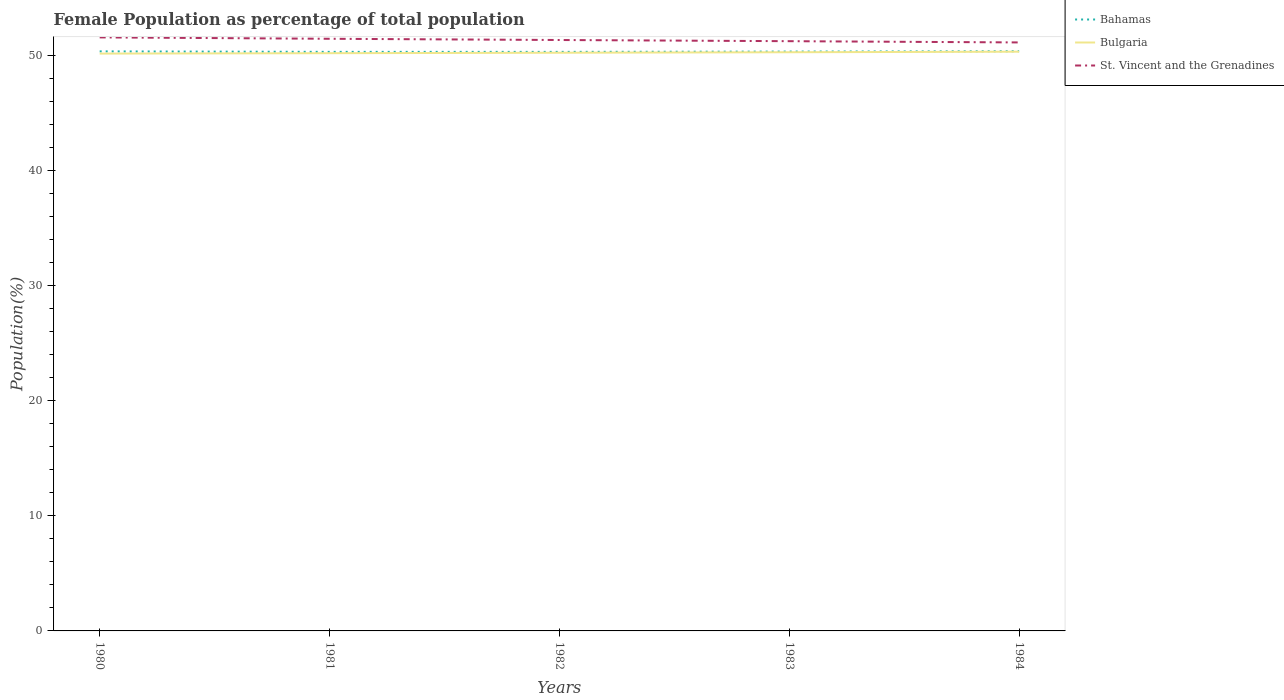Does the line corresponding to St. Vincent and the Grenadines intersect with the line corresponding to Bulgaria?
Your response must be concise. No. Is the number of lines equal to the number of legend labels?
Give a very brief answer. Yes. Across all years, what is the maximum female population in in St. Vincent and the Grenadines?
Ensure brevity in your answer.  51.13. In which year was the female population in in St. Vincent and the Grenadines maximum?
Make the answer very short. 1984. What is the total female population in in Bahamas in the graph?
Your answer should be compact. 0. What is the difference between the highest and the second highest female population in in Bahamas?
Ensure brevity in your answer.  0.05. What is the difference between the highest and the lowest female population in in St. Vincent and the Grenadines?
Ensure brevity in your answer.  2. Is the female population in in Bulgaria strictly greater than the female population in in St. Vincent and the Grenadines over the years?
Provide a succinct answer. Yes. How many lines are there?
Your response must be concise. 3. How many years are there in the graph?
Offer a terse response. 5. What is the difference between two consecutive major ticks on the Y-axis?
Make the answer very short. 10. Does the graph contain any zero values?
Your response must be concise. No. Does the graph contain grids?
Provide a short and direct response. No. Where does the legend appear in the graph?
Your response must be concise. Top right. How many legend labels are there?
Provide a short and direct response. 3. What is the title of the graph?
Your answer should be compact. Female Population as percentage of total population. Does "St. Martin (French part)" appear as one of the legend labels in the graph?
Your answer should be compact. No. What is the label or title of the Y-axis?
Make the answer very short. Population(%). What is the Population(%) of Bahamas in 1980?
Provide a short and direct response. 50.36. What is the Population(%) in Bulgaria in 1980?
Provide a short and direct response. 50.16. What is the Population(%) of St. Vincent and the Grenadines in 1980?
Your answer should be compact. 51.57. What is the Population(%) of Bahamas in 1981?
Your response must be concise. 50.31. What is the Population(%) of Bulgaria in 1981?
Give a very brief answer. 50.2. What is the Population(%) of St. Vincent and the Grenadines in 1981?
Offer a very short reply. 51.45. What is the Population(%) in Bahamas in 1982?
Offer a very short reply. 50.31. What is the Population(%) of Bulgaria in 1982?
Your answer should be very brief. 50.24. What is the Population(%) in St. Vincent and the Grenadines in 1982?
Offer a very short reply. 51.34. What is the Population(%) of Bahamas in 1983?
Give a very brief answer. 50.34. What is the Population(%) of Bulgaria in 1983?
Your answer should be compact. 50.28. What is the Population(%) in St. Vincent and the Grenadines in 1983?
Your answer should be compact. 51.24. What is the Population(%) of Bahamas in 1984?
Keep it short and to the point. 50.37. What is the Population(%) of Bulgaria in 1984?
Your response must be concise. 50.33. What is the Population(%) of St. Vincent and the Grenadines in 1984?
Your answer should be very brief. 51.13. Across all years, what is the maximum Population(%) in Bahamas?
Ensure brevity in your answer.  50.37. Across all years, what is the maximum Population(%) of Bulgaria?
Give a very brief answer. 50.33. Across all years, what is the maximum Population(%) of St. Vincent and the Grenadines?
Make the answer very short. 51.57. Across all years, what is the minimum Population(%) in Bahamas?
Provide a succinct answer. 50.31. Across all years, what is the minimum Population(%) of Bulgaria?
Offer a very short reply. 50.16. Across all years, what is the minimum Population(%) of St. Vincent and the Grenadines?
Provide a succinct answer. 51.13. What is the total Population(%) of Bahamas in the graph?
Your answer should be very brief. 251.69. What is the total Population(%) in Bulgaria in the graph?
Offer a terse response. 251.21. What is the total Population(%) in St. Vincent and the Grenadines in the graph?
Your answer should be very brief. 256.74. What is the difference between the Population(%) of Bahamas in 1980 and that in 1981?
Make the answer very short. 0.04. What is the difference between the Population(%) of Bulgaria in 1980 and that in 1981?
Provide a succinct answer. -0.03. What is the difference between the Population(%) of St. Vincent and the Grenadines in 1980 and that in 1981?
Keep it short and to the point. 0.12. What is the difference between the Population(%) of Bahamas in 1980 and that in 1982?
Your response must be concise. 0.04. What is the difference between the Population(%) of Bulgaria in 1980 and that in 1982?
Offer a terse response. -0.07. What is the difference between the Population(%) of St. Vincent and the Grenadines in 1980 and that in 1982?
Your answer should be compact. 0.23. What is the difference between the Population(%) of Bahamas in 1980 and that in 1983?
Your answer should be very brief. 0.02. What is the difference between the Population(%) in Bulgaria in 1980 and that in 1983?
Give a very brief answer. -0.12. What is the difference between the Population(%) of St. Vincent and the Grenadines in 1980 and that in 1983?
Offer a very short reply. 0.33. What is the difference between the Population(%) of Bahamas in 1980 and that in 1984?
Offer a very short reply. -0.01. What is the difference between the Population(%) of Bulgaria in 1980 and that in 1984?
Ensure brevity in your answer.  -0.17. What is the difference between the Population(%) in St. Vincent and the Grenadines in 1980 and that in 1984?
Your answer should be compact. 0.44. What is the difference between the Population(%) in Bahamas in 1981 and that in 1982?
Ensure brevity in your answer.  0. What is the difference between the Population(%) in Bulgaria in 1981 and that in 1982?
Provide a short and direct response. -0.04. What is the difference between the Population(%) of St. Vincent and the Grenadines in 1981 and that in 1982?
Your answer should be very brief. 0.11. What is the difference between the Population(%) in Bahamas in 1981 and that in 1983?
Make the answer very short. -0.02. What is the difference between the Population(%) of Bulgaria in 1981 and that in 1983?
Your answer should be very brief. -0.08. What is the difference between the Population(%) in St. Vincent and the Grenadines in 1981 and that in 1983?
Your answer should be very brief. 0.21. What is the difference between the Population(%) of Bahamas in 1981 and that in 1984?
Your answer should be very brief. -0.05. What is the difference between the Population(%) in Bulgaria in 1981 and that in 1984?
Your response must be concise. -0.13. What is the difference between the Population(%) in St. Vincent and the Grenadines in 1981 and that in 1984?
Your answer should be compact. 0.32. What is the difference between the Population(%) in Bahamas in 1982 and that in 1983?
Give a very brief answer. -0.03. What is the difference between the Population(%) in Bulgaria in 1982 and that in 1983?
Your answer should be very brief. -0.04. What is the difference between the Population(%) of St. Vincent and the Grenadines in 1982 and that in 1983?
Your answer should be very brief. 0.1. What is the difference between the Population(%) of Bahamas in 1982 and that in 1984?
Your response must be concise. -0.05. What is the difference between the Population(%) of Bulgaria in 1982 and that in 1984?
Offer a very short reply. -0.09. What is the difference between the Population(%) in St. Vincent and the Grenadines in 1982 and that in 1984?
Provide a short and direct response. 0.21. What is the difference between the Population(%) in Bahamas in 1983 and that in 1984?
Offer a very short reply. -0.03. What is the difference between the Population(%) of Bulgaria in 1983 and that in 1984?
Provide a succinct answer. -0.05. What is the difference between the Population(%) in St. Vincent and the Grenadines in 1983 and that in 1984?
Provide a short and direct response. 0.11. What is the difference between the Population(%) in Bahamas in 1980 and the Population(%) in Bulgaria in 1981?
Provide a short and direct response. 0.16. What is the difference between the Population(%) in Bahamas in 1980 and the Population(%) in St. Vincent and the Grenadines in 1981?
Ensure brevity in your answer.  -1.09. What is the difference between the Population(%) in Bulgaria in 1980 and the Population(%) in St. Vincent and the Grenadines in 1981?
Your answer should be compact. -1.29. What is the difference between the Population(%) of Bahamas in 1980 and the Population(%) of Bulgaria in 1982?
Your response must be concise. 0.12. What is the difference between the Population(%) in Bahamas in 1980 and the Population(%) in St. Vincent and the Grenadines in 1982?
Your response must be concise. -0.99. What is the difference between the Population(%) in Bulgaria in 1980 and the Population(%) in St. Vincent and the Grenadines in 1982?
Offer a terse response. -1.18. What is the difference between the Population(%) of Bahamas in 1980 and the Population(%) of Bulgaria in 1983?
Keep it short and to the point. 0.08. What is the difference between the Population(%) of Bahamas in 1980 and the Population(%) of St. Vincent and the Grenadines in 1983?
Give a very brief answer. -0.89. What is the difference between the Population(%) of Bulgaria in 1980 and the Population(%) of St. Vincent and the Grenadines in 1983?
Offer a very short reply. -1.08. What is the difference between the Population(%) of Bahamas in 1980 and the Population(%) of Bulgaria in 1984?
Offer a terse response. 0.03. What is the difference between the Population(%) in Bahamas in 1980 and the Population(%) in St. Vincent and the Grenadines in 1984?
Make the answer very short. -0.78. What is the difference between the Population(%) in Bulgaria in 1980 and the Population(%) in St. Vincent and the Grenadines in 1984?
Offer a very short reply. -0.97. What is the difference between the Population(%) in Bahamas in 1981 and the Population(%) in Bulgaria in 1982?
Your answer should be very brief. 0.08. What is the difference between the Population(%) in Bahamas in 1981 and the Population(%) in St. Vincent and the Grenadines in 1982?
Your response must be concise. -1.03. What is the difference between the Population(%) in Bulgaria in 1981 and the Population(%) in St. Vincent and the Grenadines in 1982?
Keep it short and to the point. -1.15. What is the difference between the Population(%) in Bahamas in 1981 and the Population(%) in Bulgaria in 1983?
Your response must be concise. 0.03. What is the difference between the Population(%) of Bahamas in 1981 and the Population(%) of St. Vincent and the Grenadines in 1983?
Make the answer very short. -0.93. What is the difference between the Population(%) of Bulgaria in 1981 and the Population(%) of St. Vincent and the Grenadines in 1983?
Provide a short and direct response. -1.04. What is the difference between the Population(%) of Bahamas in 1981 and the Population(%) of Bulgaria in 1984?
Make the answer very short. -0.01. What is the difference between the Population(%) of Bahamas in 1981 and the Population(%) of St. Vincent and the Grenadines in 1984?
Provide a succinct answer. -0.82. What is the difference between the Population(%) in Bulgaria in 1981 and the Population(%) in St. Vincent and the Grenadines in 1984?
Provide a short and direct response. -0.93. What is the difference between the Population(%) of Bahamas in 1982 and the Population(%) of Bulgaria in 1983?
Ensure brevity in your answer.  0.03. What is the difference between the Population(%) in Bahamas in 1982 and the Population(%) in St. Vincent and the Grenadines in 1983?
Provide a succinct answer. -0.93. What is the difference between the Population(%) of Bulgaria in 1982 and the Population(%) of St. Vincent and the Grenadines in 1983?
Provide a short and direct response. -1. What is the difference between the Population(%) of Bahamas in 1982 and the Population(%) of Bulgaria in 1984?
Make the answer very short. -0.02. What is the difference between the Population(%) of Bahamas in 1982 and the Population(%) of St. Vincent and the Grenadines in 1984?
Provide a succinct answer. -0.82. What is the difference between the Population(%) of Bulgaria in 1982 and the Population(%) of St. Vincent and the Grenadines in 1984?
Offer a terse response. -0.9. What is the difference between the Population(%) in Bahamas in 1983 and the Population(%) in Bulgaria in 1984?
Offer a very short reply. 0.01. What is the difference between the Population(%) of Bahamas in 1983 and the Population(%) of St. Vincent and the Grenadines in 1984?
Your answer should be compact. -0.79. What is the difference between the Population(%) of Bulgaria in 1983 and the Population(%) of St. Vincent and the Grenadines in 1984?
Provide a succinct answer. -0.85. What is the average Population(%) of Bahamas per year?
Offer a very short reply. 50.34. What is the average Population(%) of Bulgaria per year?
Provide a short and direct response. 50.24. What is the average Population(%) of St. Vincent and the Grenadines per year?
Provide a succinct answer. 51.35. In the year 1980, what is the difference between the Population(%) of Bahamas and Population(%) of Bulgaria?
Your response must be concise. 0.19. In the year 1980, what is the difference between the Population(%) of Bahamas and Population(%) of St. Vincent and the Grenadines?
Your answer should be compact. -1.22. In the year 1980, what is the difference between the Population(%) of Bulgaria and Population(%) of St. Vincent and the Grenadines?
Ensure brevity in your answer.  -1.41. In the year 1981, what is the difference between the Population(%) of Bahamas and Population(%) of Bulgaria?
Your answer should be compact. 0.12. In the year 1981, what is the difference between the Population(%) in Bahamas and Population(%) in St. Vincent and the Grenadines?
Make the answer very short. -1.14. In the year 1981, what is the difference between the Population(%) in Bulgaria and Population(%) in St. Vincent and the Grenadines?
Ensure brevity in your answer.  -1.25. In the year 1982, what is the difference between the Population(%) of Bahamas and Population(%) of Bulgaria?
Your response must be concise. 0.08. In the year 1982, what is the difference between the Population(%) of Bahamas and Population(%) of St. Vincent and the Grenadines?
Provide a succinct answer. -1.03. In the year 1982, what is the difference between the Population(%) of Bulgaria and Population(%) of St. Vincent and the Grenadines?
Your answer should be compact. -1.11. In the year 1983, what is the difference between the Population(%) in Bahamas and Population(%) in Bulgaria?
Provide a succinct answer. 0.06. In the year 1983, what is the difference between the Population(%) of Bahamas and Population(%) of St. Vincent and the Grenadines?
Keep it short and to the point. -0.9. In the year 1983, what is the difference between the Population(%) of Bulgaria and Population(%) of St. Vincent and the Grenadines?
Give a very brief answer. -0.96. In the year 1984, what is the difference between the Population(%) in Bahamas and Population(%) in Bulgaria?
Your answer should be compact. 0.04. In the year 1984, what is the difference between the Population(%) in Bahamas and Population(%) in St. Vincent and the Grenadines?
Your answer should be very brief. -0.77. In the year 1984, what is the difference between the Population(%) of Bulgaria and Population(%) of St. Vincent and the Grenadines?
Offer a very short reply. -0.8. What is the ratio of the Population(%) of Bahamas in 1980 to that in 1982?
Give a very brief answer. 1. What is the ratio of the Population(%) in Bulgaria in 1980 to that in 1982?
Offer a very short reply. 1. What is the ratio of the Population(%) in Bahamas in 1980 to that in 1983?
Offer a terse response. 1. What is the ratio of the Population(%) of Bulgaria in 1980 to that in 1983?
Keep it short and to the point. 1. What is the ratio of the Population(%) of St. Vincent and the Grenadines in 1980 to that in 1983?
Keep it short and to the point. 1.01. What is the ratio of the Population(%) of Bahamas in 1980 to that in 1984?
Your answer should be compact. 1. What is the ratio of the Population(%) of Bulgaria in 1980 to that in 1984?
Your answer should be very brief. 1. What is the ratio of the Population(%) in St. Vincent and the Grenadines in 1980 to that in 1984?
Keep it short and to the point. 1.01. What is the ratio of the Population(%) in Bulgaria in 1981 to that in 1982?
Keep it short and to the point. 1. What is the ratio of the Population(%) of St. Vincent and the Grenadines in 1981 to that in 1982?
Ensure brevity in your answer.  1. What is the ratio of the Population(%) in Bahamas in 1981 to that in 1983?
Your answer should be very brief. 1. What is the ratio of the Population(%) of Bulgaria in 1981 to that in 1983?
Offer a very short reply. 1. What is the ratio of the Population(%) of St. Vincent and the Grenadines in 1981 to that in 1983?
Your answer should be very brief. 1. What is the ratio of the Population(%) of Bahamas in 1981 to that in 1984?
Give a very brief answer. 1. What is the ratio of the Population(%) in Bulgaria in 1981 to that in 1984?
Your response must be concise. 1. What is the ratio of the Population(%) in St. Vincent and the Grenadines in 1981 to that in 1984?
Your answer should be very brief. 1.01. What is the ratio of the Population(%) of St. Vincent and the Grenadines in 1983 to that in 1984?
Keep it short and to the point. 1. What is the difference between the highest and the second highest Population(%) of Bahamas?
Ensure brevity in your answer.  0.01. What is the difference between the highest and the second highest Population(%) in Bulgaria?
Offer a very short reply. 0.05. What is the difference between the highest and the second highest Population(%) in St. Vincent and the Grenadines?
Your response must be concise. 0.12. What is the difference between the highest and the lowest Population(%) of Bahamas?
Your answer should be very brief. 0.05. What is the difference between the highest and the lowest Population(%) of Bulgaria?
Give a very brief answer. 0.17. What is the difference between the highest and the lowest Population(%) in St. Vincent and the Grenadines?
Ensure brevity in your answer.  0.44. 